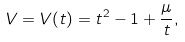Convert formula to latex. <formula><loc_0><loc_0><loc_500><loc_500>V = V ( t ) = t ^ { 2 } - 1 + \frac { \mu } { t } ,</formula> 